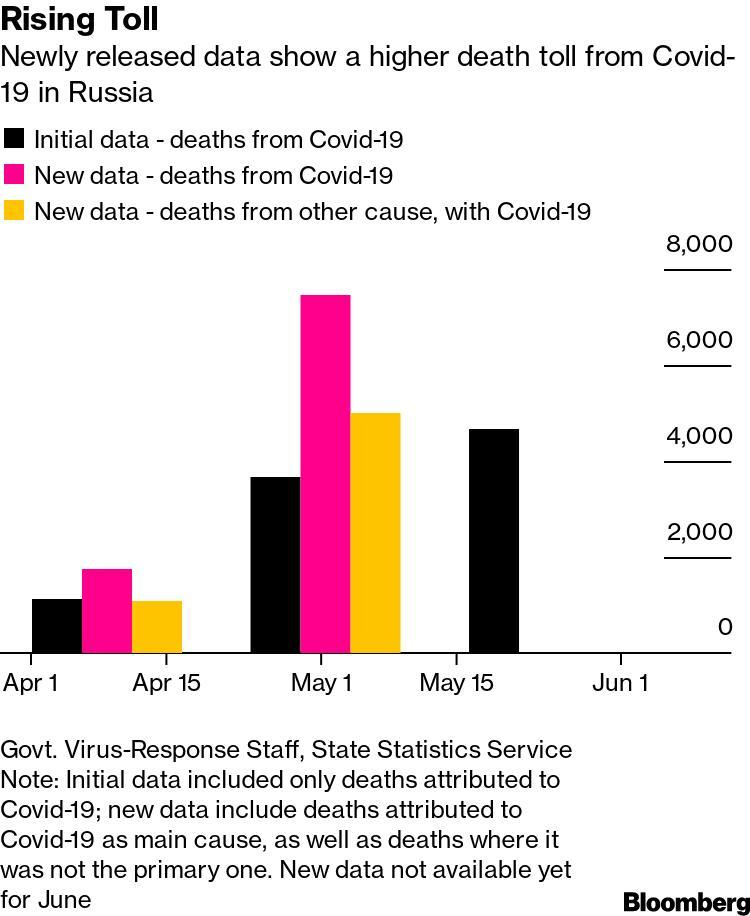How many months are mentioned in the graph?
Answer the question with a short phrase. 3 